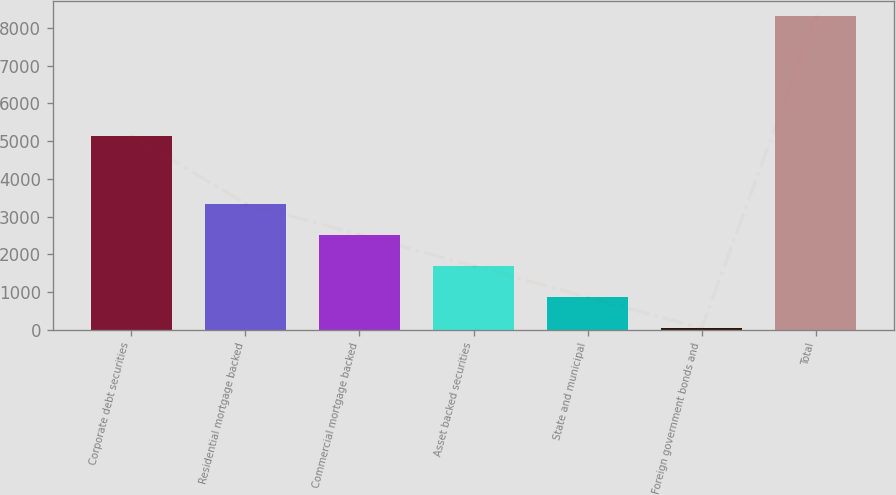Convert chart. <chart><loc_0><loc_0><loc_500><loc_500><bar_chart><fcel>Corporate debt securities<fcel>Residential mortgage backed<fcel>Commercial mortgage backed<fcel>Asset backed securities<fcel>State and municipal<fcel>Foreign government bonds and<fcel>Total<nl><fcel>5150<fcel>3346.6<fcel>2519.7<fcel>1692.8<fcel>865.9<fcel>39<fcel>8308<nl></chart> 